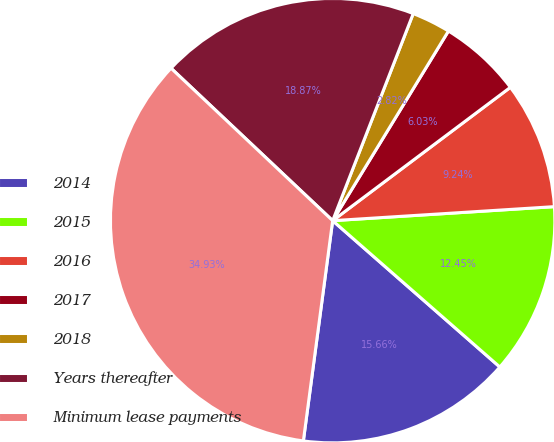Convert chart to OTSL. <chart><loc_0><loc_0><loc_500><loc_500><pie_chart><fcel>2014<fcel>2015<fcel>2016<fcel>2017<fcel>2018<fcel>Years thereafter<fcel>Minimum lease payments<nl><fcel>15.66%<fcel>12.45%<fcel>9.24%<fcel>6.03%<fcel>2.82%<fcel>18.87%<fcel>34.93%<nl></chart> 